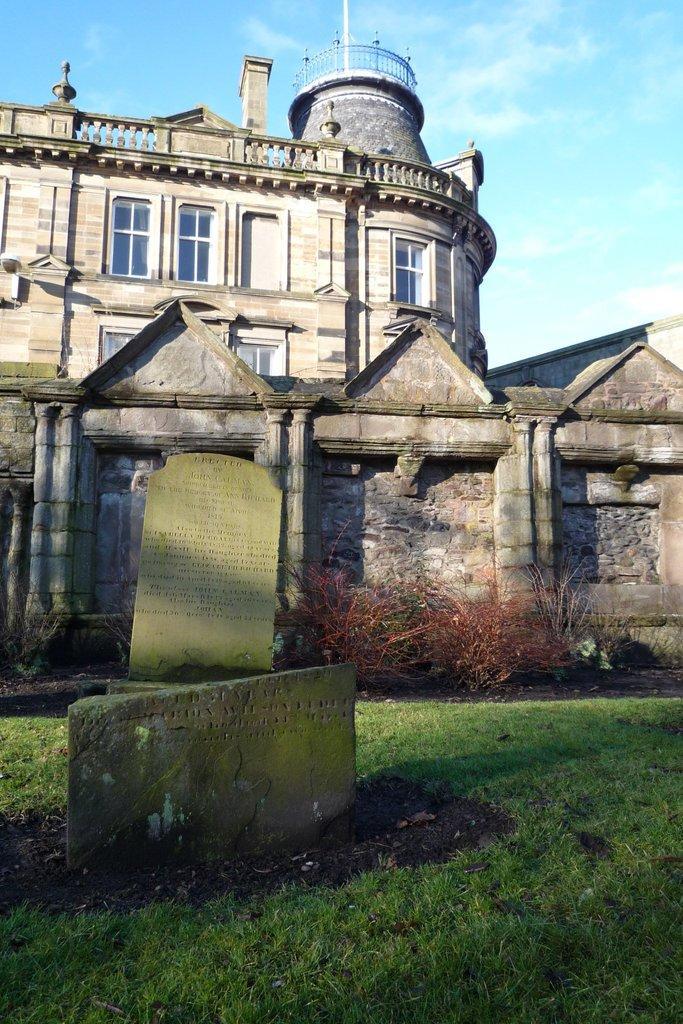In one or two sentences, can you explain what this image depicts? At the center of the image there is a building, in front of the building there are some plants and there are stones are placed on the surface of the grass. In the background there is a sky. 